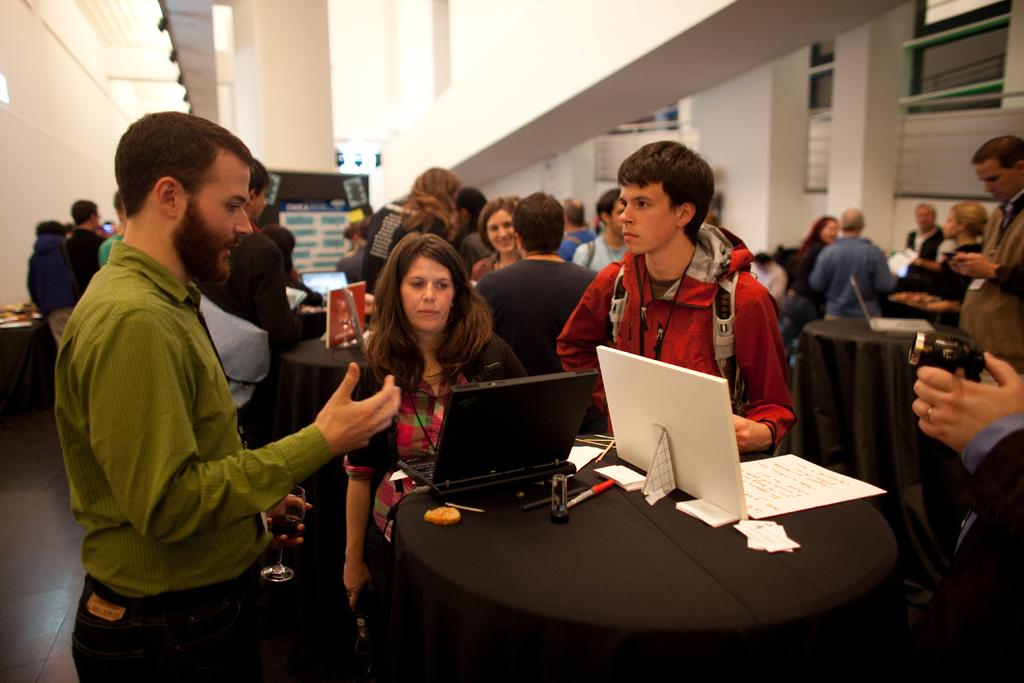How many people are in the image? There is a group of people in the image. What is on the table in the image? There is a laptop, a pen, paper, and tissue on the table. What can be seen in the background of the image? There is a window, a curtain, and a pillar in the background of the image. What type of feeling can be seen on the pancake in the image? There is no pancake present in the image, so it is not possible to determine any feelings on a pancake. 